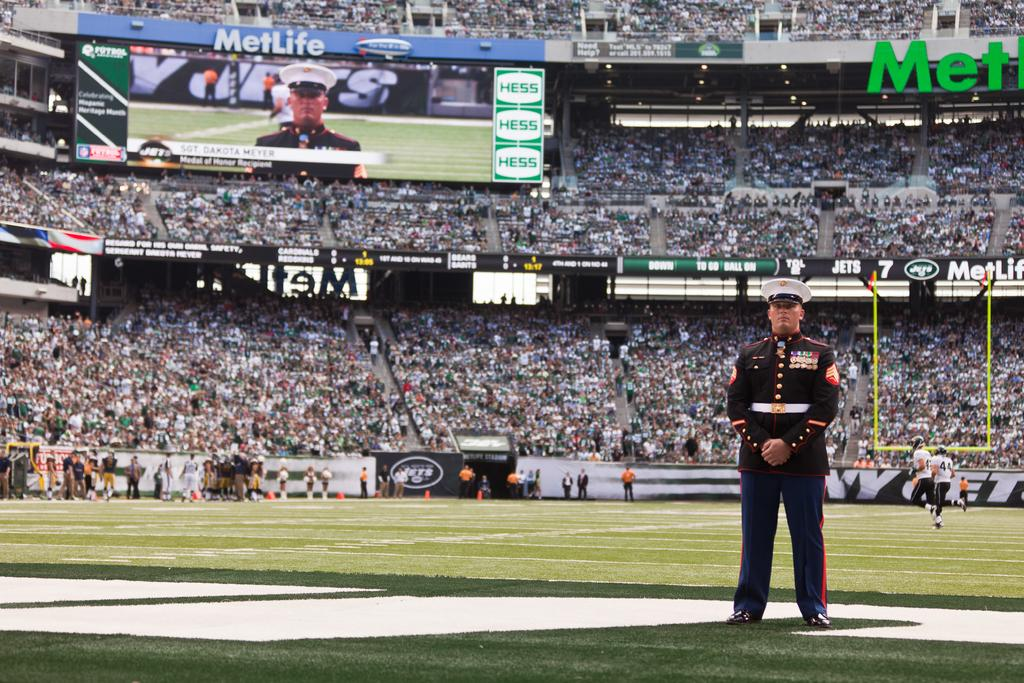<image>
Offer a succinct explanation of the picture presented. A soldier at a football game down in the field sponsor by Metlife. 